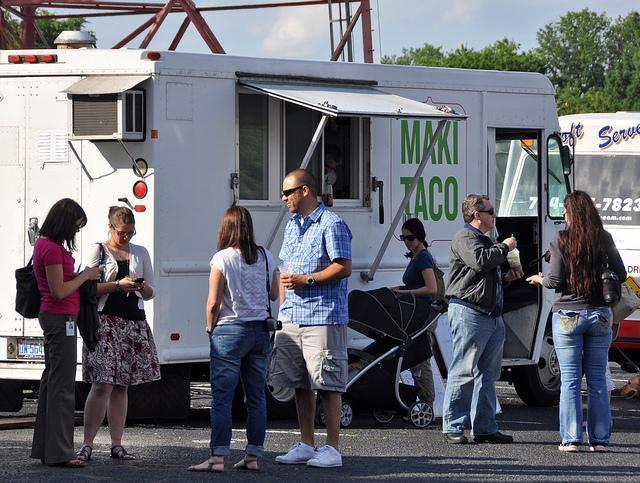How many people can be seen?
Give a very brief answer. 7. 